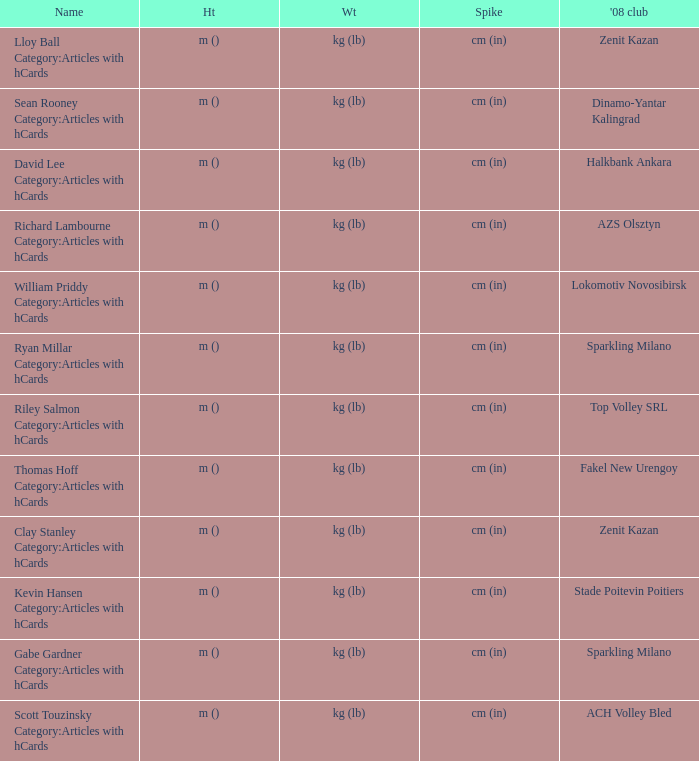What name has Fakel New Urengoy as the 2008 club? Thomas Hoff Category:Articles with hCards. 